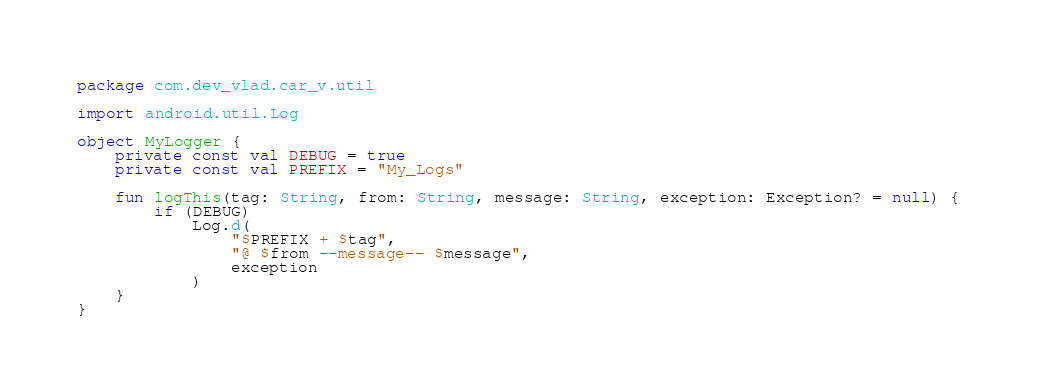<code> <loc_0><loc_0><loc_500><loc_500><_Kotlin_>package com.dev_vlad.car_v.util

import android.util.Log

object MyLogger {
    private const val DEBUG = true
    private const val PREFIX = "My_Logs"

    fun logThis(tag: String, from: String, message: String, exception: Exception? = null) {
        if (DEBUG)
            Log.d(
                "$PREFIX + $tag",
                "@ $from --message-- $message",
                exception
            )
    }
}</code> 